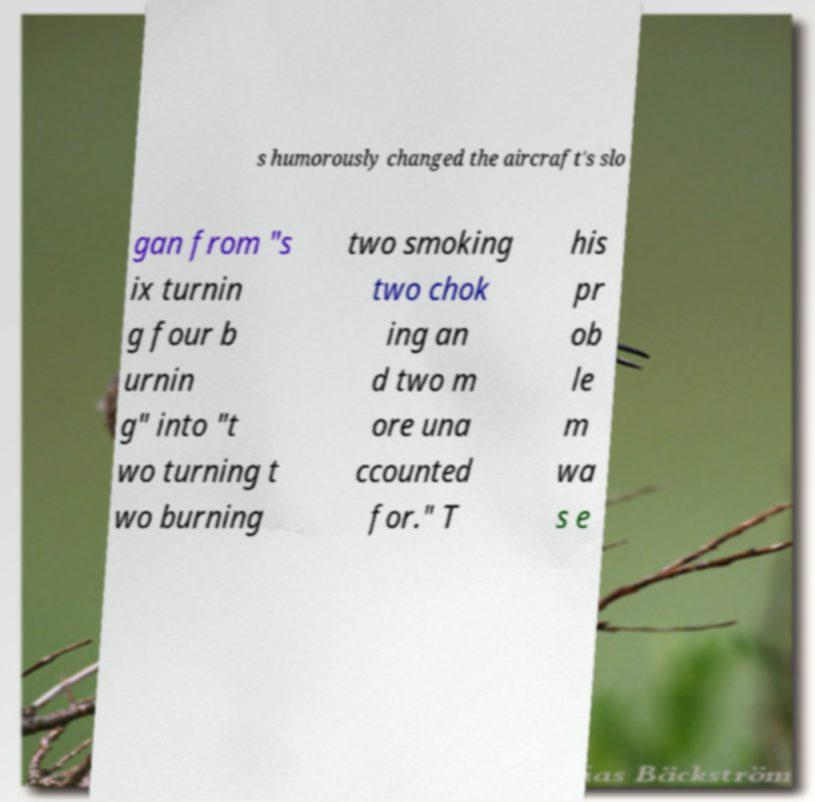Please identify and transcribe the text found in this image. s humorously changed the aircraft's slo gan from "s ix turnin g four b urnin g" into "t wo turning t wo burning two smoking two chok ing an d two m ore una ccounted for." T his pr ob le m wa s e 